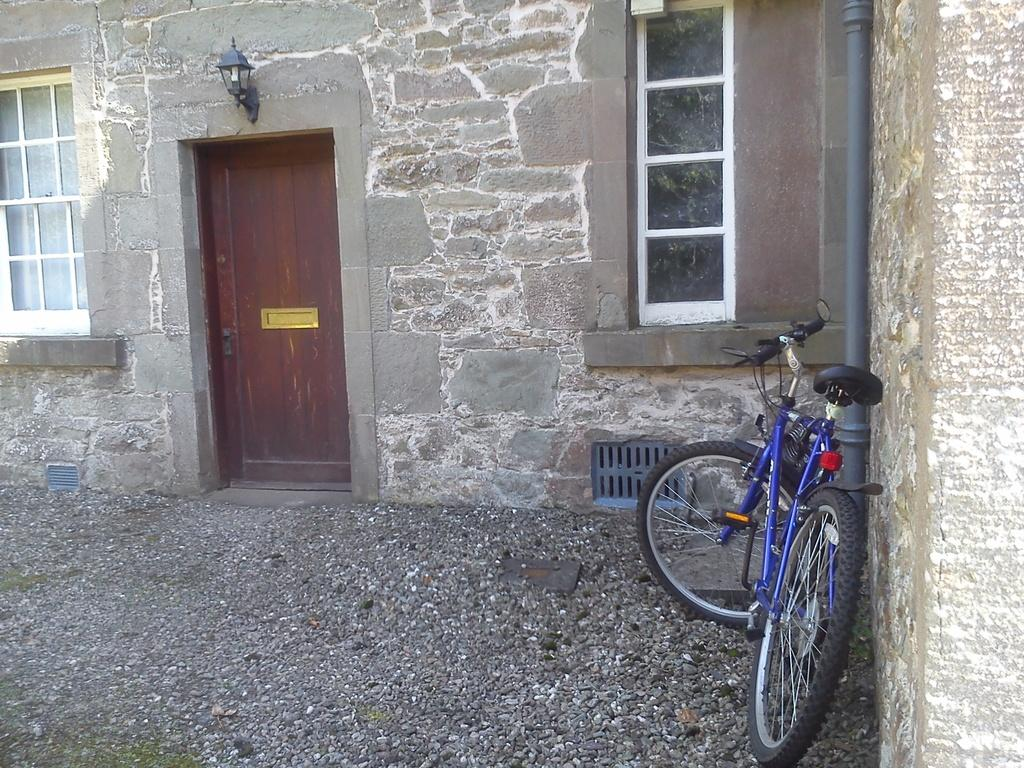What is the main object in the image? There is a bicycle in the image. Where is the bicycle located in relation to other objects? The bicycle is beside a pipe. What type of structure can be seen in the image? There is a building in the image. What can be used to illuminate the area in the image? There is a light in the image. What feature allows natural light to enter the building in the image? There are windows in the image. What type of texture can be seen on the wooden plate in the image? There is no wooden plate present in the image. 